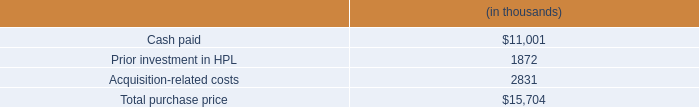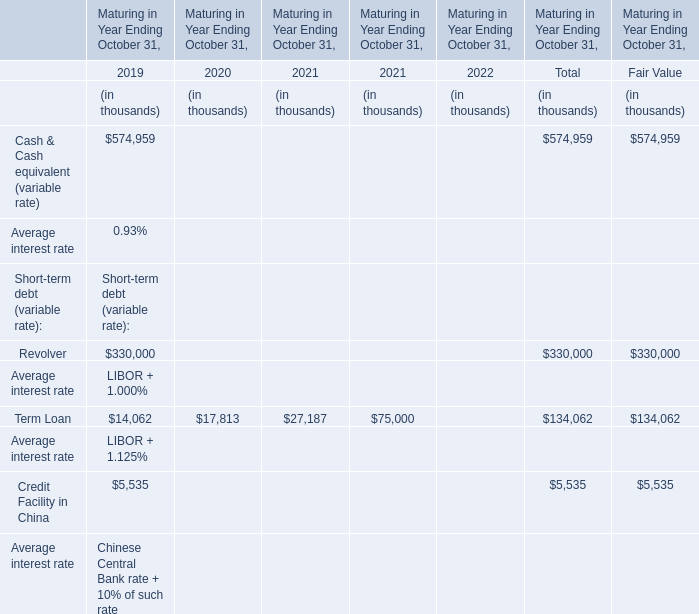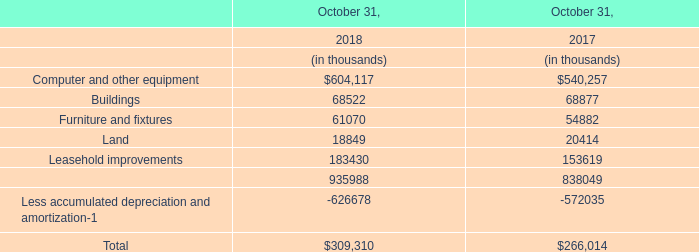what is the percentage of tax and accounting fees among the total acquisition-related costs? 
Computations: (1.6 / 2.8)
Answer: 0.57143. 